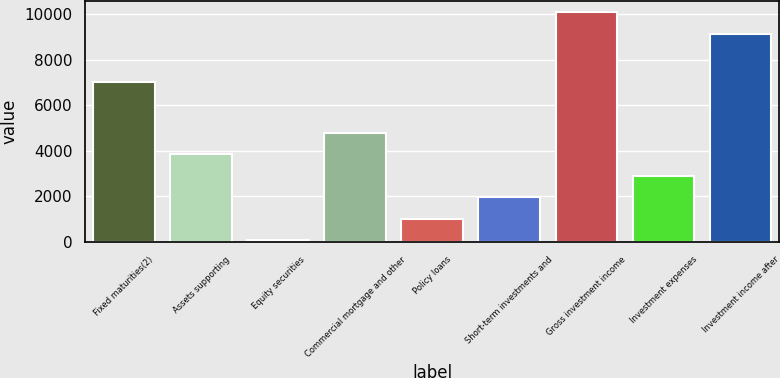Convert chart. <chart><loc_0><loc_0><loc_500><loc_500><bar_chart><fcel>Fixed maturities(2)<fcel>Assets supporting<fcel>Equity securities<fcel>Commercial mortgage and other<fcel>Policy loans<fcel>Short-term investments and<fcel>Gross investment income<fcel>Investment expenses<fcel>Investment income after<nl><fcel>7004<fcel>3848<fcel>48<fcel>4798<fcel>998<fcel>1948<fcel>10101<fcel>2898<fcel>9151<nl></chart> 